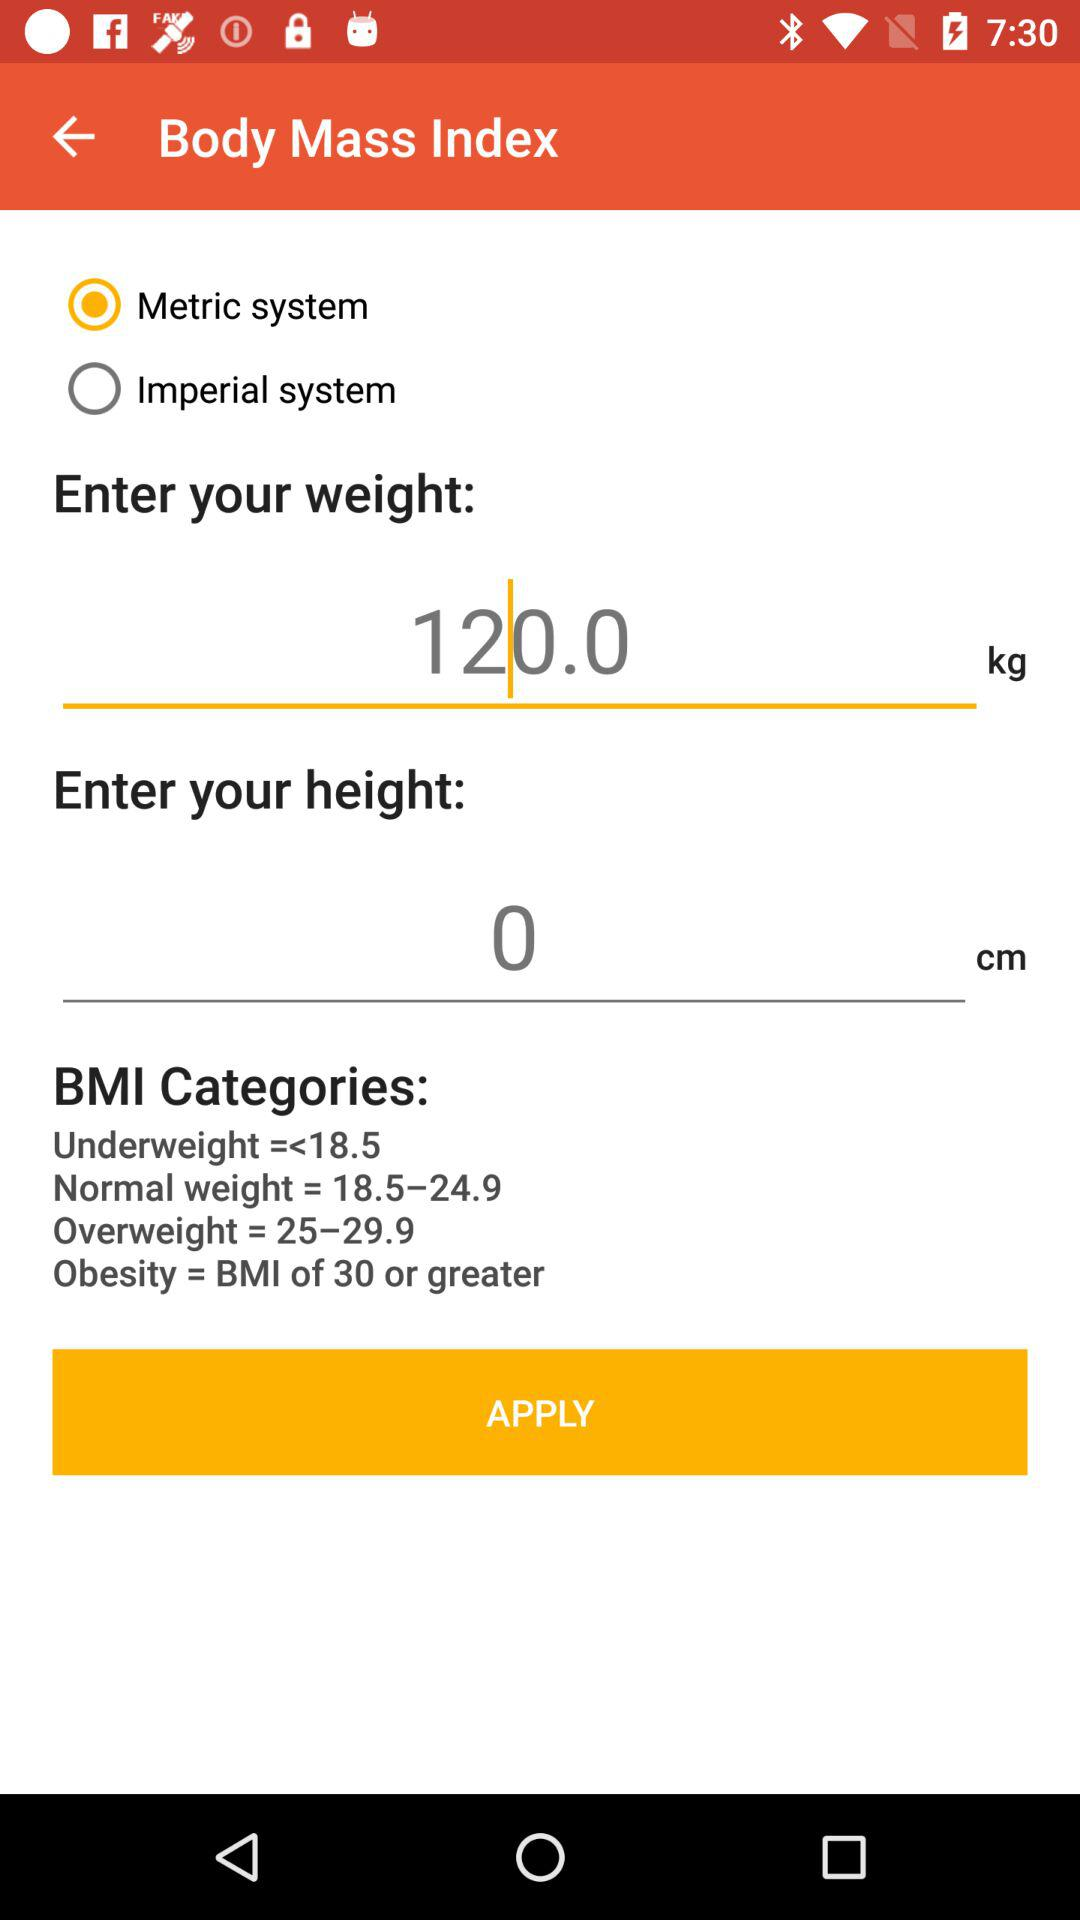What is the unit of weight? The unit of weight is kg. 